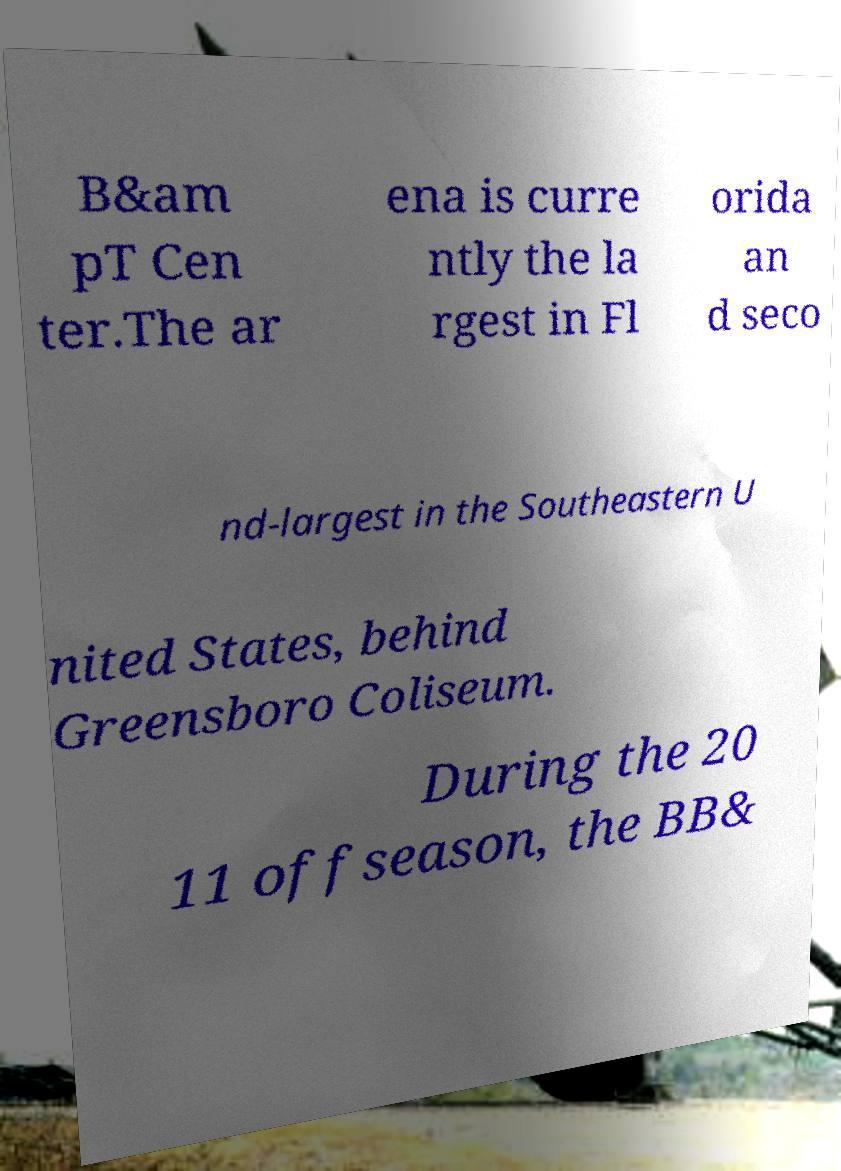There's text embedded in this image that I need extracted. Can you transcribe it verbatim? B&am pT Cen ter.The ar ena is curre ntly the la rgest in Fl orida an d seco nd-largest in the Southeastern U nited States, behind Greensboro Coliseum. During the 20 11 offseason, the BB& 